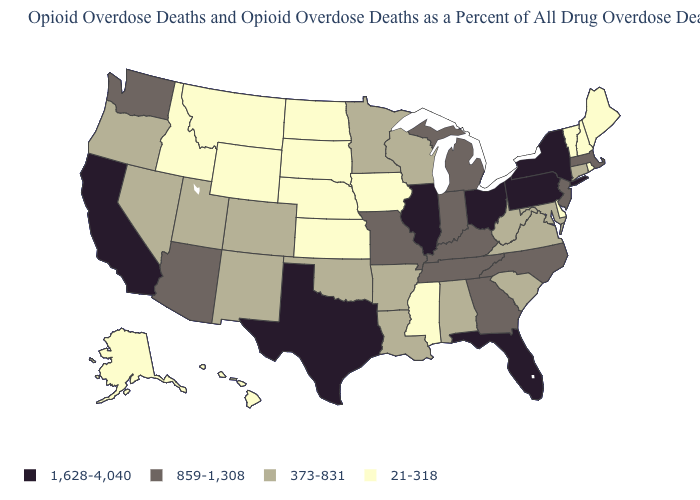Which states have the lowest value in the Northeast?
Write a very short answer. Maine, New Hampshire, Rhode Island, Vermont. What is the value of Nebraska?
Answer briefly. 21-318. What is the value of Washington?
Short answer required. 859-1,308. What is the value of Oregon?
Keep it brief. 373-831. Name the states that have a value in the range 373-831?
Short answer required. Alabama, Arkansas, Colorado, Connecticut, Louisiana, Maryland, Minnesota, Nevada, New Mexico, Oklahoma, Oregon, South Carolina, Utah, Virginia, West Virginia, Wisconsin. Does the map have missing data?
Concise answer only. No. What is the value of Washington?
Concise answer only. 859-1,308. What is the highest value in the West ?
Be succinct. 1,628-4,040. What is the lowest value in the USA?
Answer briefly. 21-318. What is the value of New Jersey?
Keep it brief. 859-1,308. What is the lowest value in the South?
Answer briefly. 21-318. Does New Mexico have a lower value than Nevada?
Concise answer only. No. What is the highest value in the MidWest ?
Quick response, please. 1,628-4,040. Does New Mexico have a lower value than Rhode Island?
Write a very short answer. No. What is the value of North Dakota?
Give a very brief answer. 21-318. 